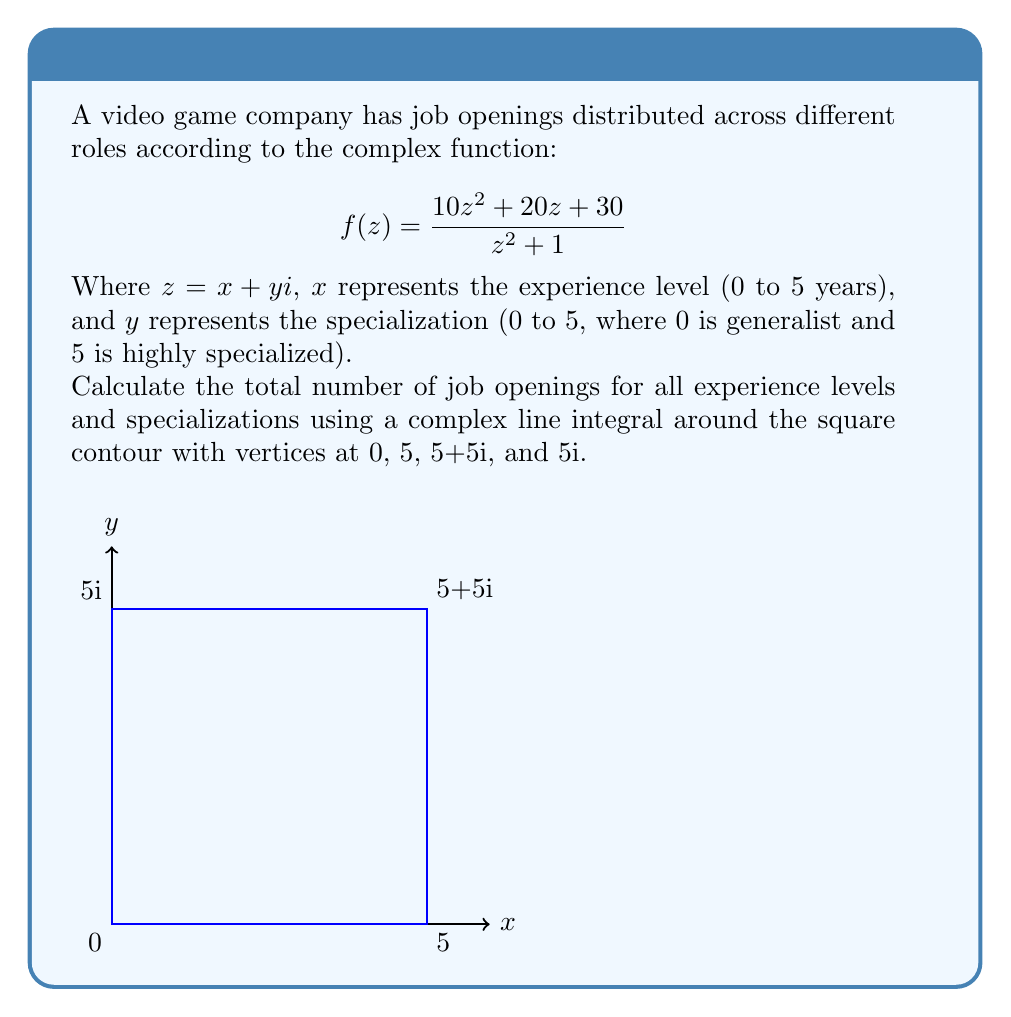Solve this math problem. To solve this problem, we'll use the Cauchy-Goursat theorem and the residue theorem from complex analysis. Here's the step-by-step solution:

1) The Cauchy-Goursat theorem states that for an analytic function $f(z)$ inside and on a simple closed contour $C$:

   $$\oint_C f(z) dz = 2\pi i \sum \text{Res}(f, a_k)$$

   where $a_k$ are the poles of $f(z)$ inside $C$.

2) Our function $f(z) = \frac{10z^2 + 20z + 30}{z^2 + 1}$ has poles at $z = \pm i$.

3) The contour encloses only the pole at $z = i$, so we only need to calculate the residue at this point.

4) To find the residue, we use the formula for a simple pole:

   $$\text{Res}(f, i) = \lim_{z \to i} (z-i)f(z)$$

5) Calculating:
   $$\begin{align}
   \text{Res}(f, i) &= \lim_{z \to i} (z-i)\frac{10z^2 + 20z + 30}{z^2 + 1} \\
   &= \lim_{z \to i} \frac{10z^2 + 20z + 30}{z+i} \\
   &= \frac{10i^2 + 20i + 30}{i+i} \\
   &= \frac{-10 + 20i + 30}{2i} \\
   &= \frac{20 + 20i}{2i} \\
   &= 10 - 10i
   \end{align}$$

6) Applying the residue theorem:

   $$\oint_C f(z) dz = 2\pi i (10 - 10i) = 20\pi + 20\pi i$$

7) The real part of this result, $20\pi$, represents the total number of job openings.
Answer: $20\pi$ job openings 